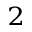<formula> <loc_0><loc_0><loc_500><loc_500>_ { 2 }</formula> 